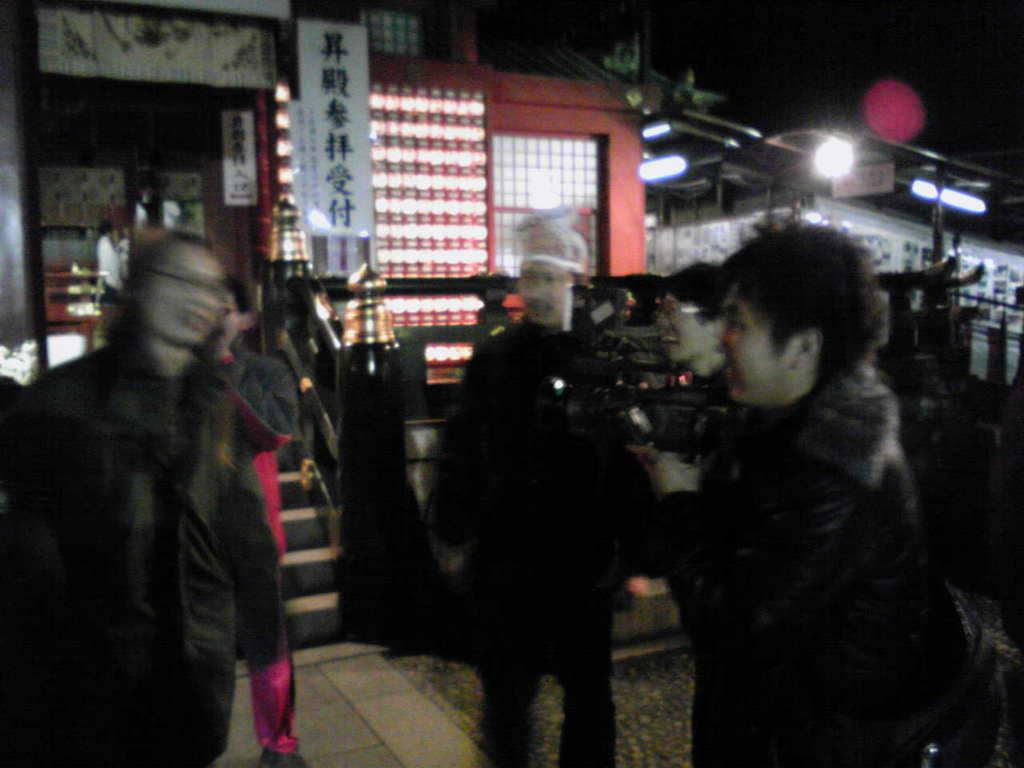What type of structures can be seen in the image? There are buildings in the image. What objects are visible on the buildings? Boards, lights, and iron rods are visible in the image. Where are the stairs located in the image? The stairs are on the left side of the image. What is present at the bottom of the image? There is a walkway at the bottom of the image. Can you see a snake slithering on the walkway in the image? There is no snake present in the image; it only features buildings, boards, lights, iron rods, stairs, and a walkway. 